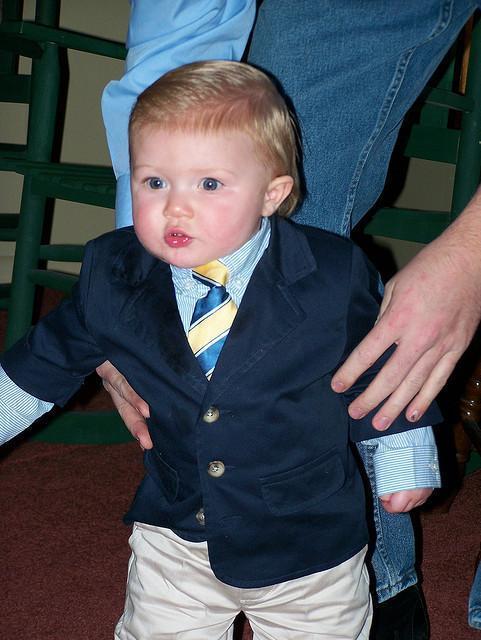How many buttons are on his jacket?
Give a very brief answer. 3. How many people are in the picture?
Give a very brief answer. 2. 